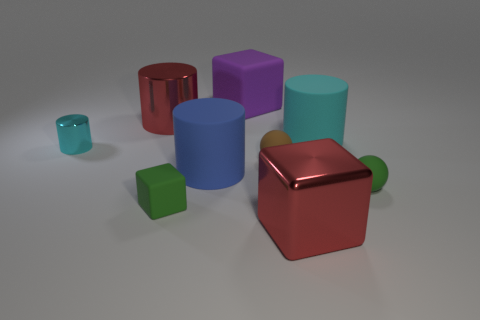What is the color of the shiny thing right of the large purple cube?
Keep it short and to the point. Red. What is the shape of the large blue rubber thing?
Offer a terse response. Cylinder. There is a tiny thing that is on the left side of the large red thing on the left side of the large purple matte cube; what is it made of?
Provide a short and direct response. Metal. What number of other things are the same material as the brown thing?
Provide a short and direct response. 5. What is the material of the blue cylinder that is the same size as the red block?
Your answer should be compact. Rubber. Are there more cyan matte objects that are behind the red shiny cylinder than small green balls in front of the green matte block?
Your answer should be compact. No. Are there any large purple shiny objects that have the same shape as the big cyan thing?
Offer a terse response. No. What is the shape of the brown matte object that is the same size as the cyan metallic cylinder?
Your response must be concise. Sphere. There is a red object behind the small green rubber sphere; what shape is it?
Ensure brevity in your answer.  Cylinder. Are there fewer green blocks that are in front of the large red metallic block than big red metal cylinders that are behind the small brown rubber thing?
Offer a terse response. Yes. 